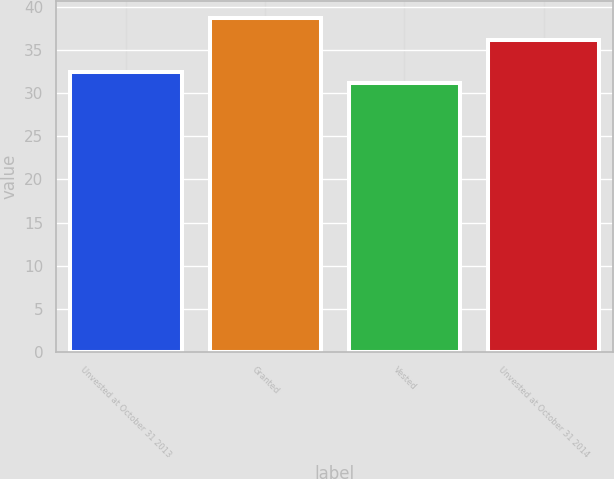Convert chart. <chart><loc_0><loc_0><loc_500><loc_500><bar_chart><fcel>Unvested at October 31 2013<fcel>Granted<fcel>Vested<fcel>Unvested at October 31 2014<nl><fcel>32.48<fcel>38.7<fcel>31.18<fcel>36.09<nl></chart> 